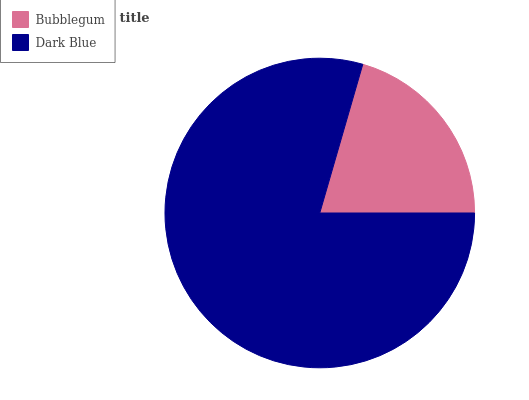Is Bubblegum the minimum?
Answer yes or no. Yes. Is Dark Blue the maximum?
Answer yes or no. Yes. Is Dark Blue the minimum?
Answer yes or no. No. Is Dark Blue greater than Bubblegum?
Answer yes or no. Yes. Is Bubblegum less than Dark Blue?
Answer yes or no. Yes. Is Bubblegum greater than Dark Blue?
Answer yes or no. No. Is Dark Blue less than Bubblegum?
Answer yes or no. No. Is Dark Blue the high median?
Answer yes or no. Yes. Is Bubblegum the low median?
Answer yes or no. Yes. Is Bubblegum the high median?
Answer yes or no. No. Is Dark Blue the low median?
Answer yes or no. No. 